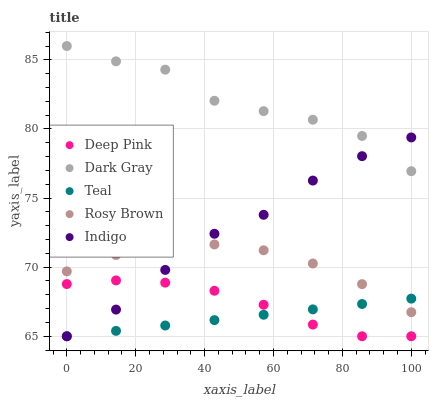Does Teal have the minimum area under the curve?
Answer yes or no. Yes. Does Dark Gray have the maximum area under the curve?
Answer yes or no. Yes. Does Rosy Brown have the minimum area under the curve?
Answer yes or no. No. Does Rosy Brown have the maximum area under the curve?
Answer yes or no. No. Is Teal the smoothest?
Answer yes or no. Yes. Is Dark Gray the roughest?
Answer yes or no. Yes. Is Rosy Brown the smoothest?
Answer yes or no. No. Is Rosy Brown the roughest?
Answer yes or no. No. Does Deep Pink have the lowest value?
Answer yes or no. Yes. Does Rosy Brown have the lowest value?
Answer yes or no. No. Does Dark Gray have the highest value?
Answer yes or no. Yes. Does Rosy Brown have the highest value?
Answer yes or no. No. Is Teal less than Dark Gray?
Answer yes or no. Yes. Is Dark Gray greater than Deep Pink?
Answer yes or no. Yes. Does Indigo intersect Teal?
Answer yes or no. Yes. Is Indigo less than Teal?
Answer yes or no. No. Is Indigo greater than Teal?
Answer yes or no. No. Does Teal intersect Dark Gray?
Answer yes or no. No. 